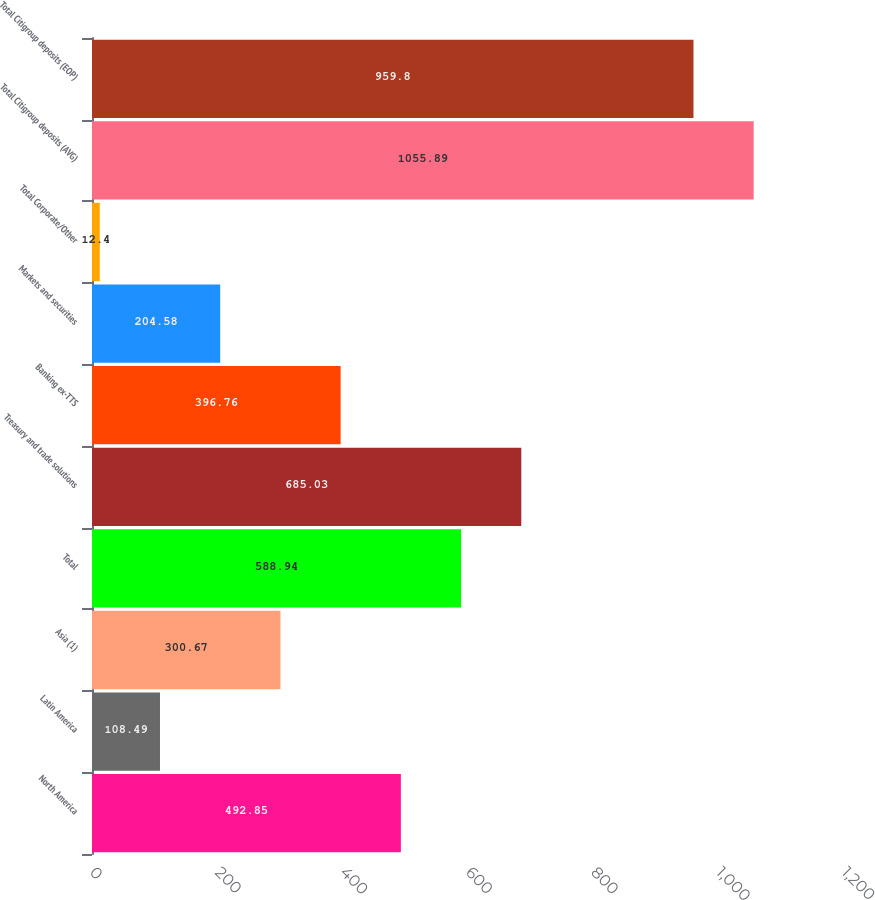Convert chart to OTSL. <chart><loc_0><loc_0><loc_500><loc_500><bar_chart><fcel>North America<fcel>Latin America<fcel>Asia (1)<fcel>Total<fcel>Treasury and trade solutions<fcel>Banking ex-TTS<fcel>Markets and securities<fcel>Total Corporate/Other<fcel>Total Citigroup deposits (AVG)<fcel>Total Citigroup deposits (EOP)<nl><fcel>492.85<fcel>108.49<fcel>300.67<fcel>588.94<fcel>685.03<fcel>396.76<fcel>204.58<fcel>12.4<fcel>1055.89<fcel>959.8<nl></chart> 